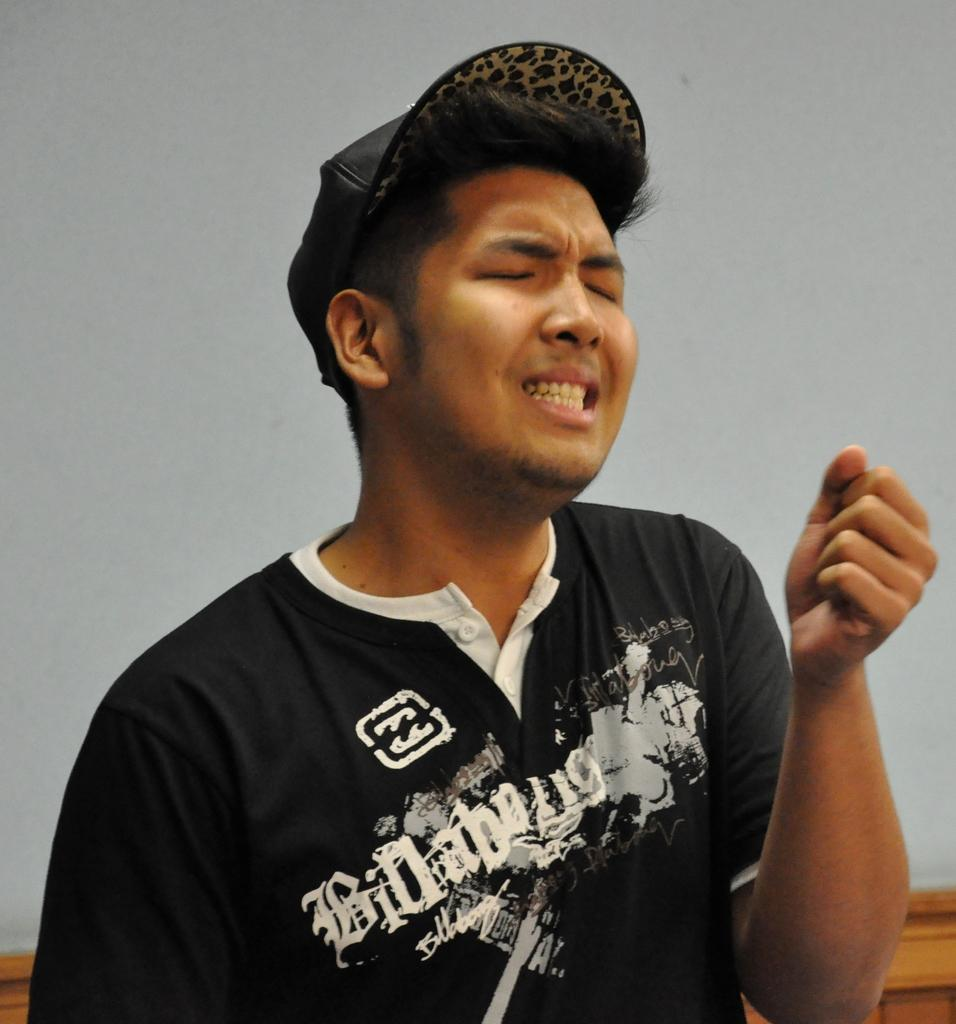Who is present in the image? There is a man in the image. What is the man wearing on his head? The man is wearing a cap. What can be seen in the background of the image? There is a wooden object and a wall in the background of the image. How does the actor cry in the image? There is no actor or crying depicted in the image; it features a man wearing a cap. 